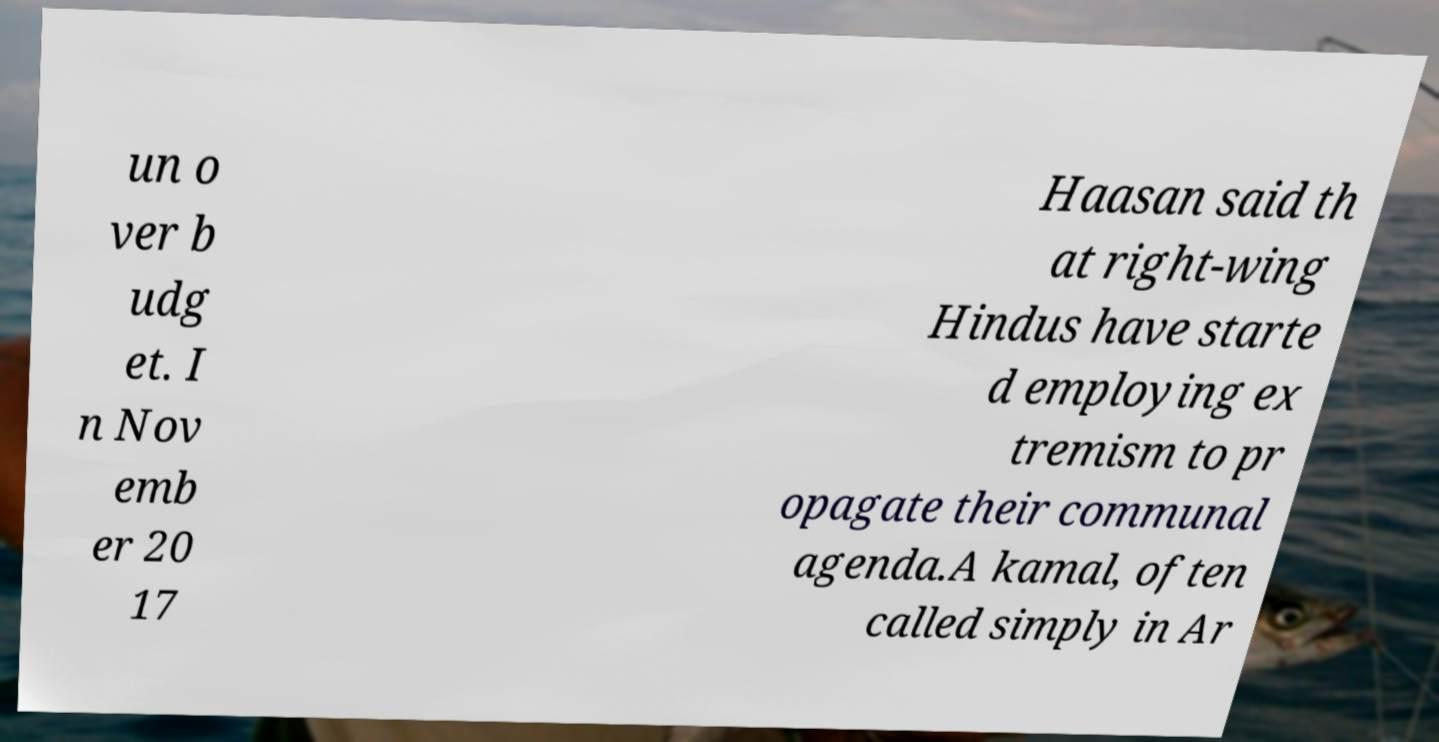Can you accurately transcribe the text from the provided image for me? un o ver b udg et. I n Nov emb er 20 17 Haasan said th at right-wing Hindus have starte d employing ex tremism to pr opagate their communal agenda.A kamal, often called simply in Ar 